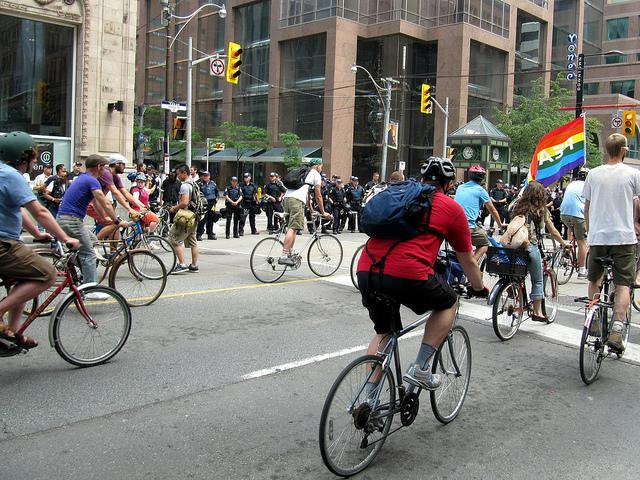Why are the men in uniforms standing by the road?

Choices:
A) street workers
B) entertainment
C) doctors
D) security security 